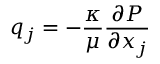Convert formula to latex. <formula><loc_0><loc_0><loc_500><loc_500>q _ { j } = - { \frac { \kappa } { \mu } } { \frac { \partial P } { \partial x _ { j } } }</formula> 